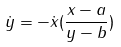Convert formula to latex. <formula><loc_0><loc_0><loc_500><loc_500>\dot { y } = - \dot { x } ( \frac { x - a } { y - b } )</formula> 